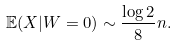Convert formula to latex. <formula><loc_0><loc_0><loc_500><loc_500>\mathbb { E } ( X | W = 0 ) \sim \frac { \log 2 } { 8 } n .</formula> 